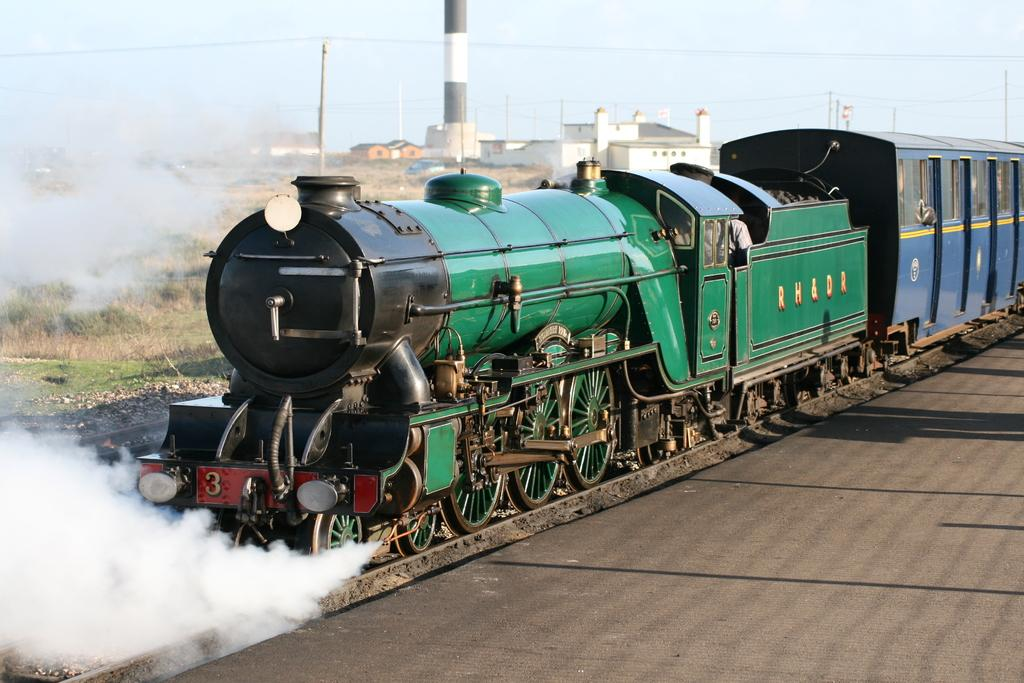What is the main subject of the image? The main subject of the image is a train. Where is the train located? The train is on a railway track. What can be seen in front of the train? There is smoke in front of the train. What is visible behind the train? There is a factory behind the train. What structures are present in the background? There are poles with cables and grass in the background. What is visible in the sky? The sky is visible in the background. What type of base is being used by the workers in the image? There are no workers or bases present in the image; it features a train on a railway track with a factory and other background elements. What activity is the hammer being used for in the image? There is no hammer present in the image. 